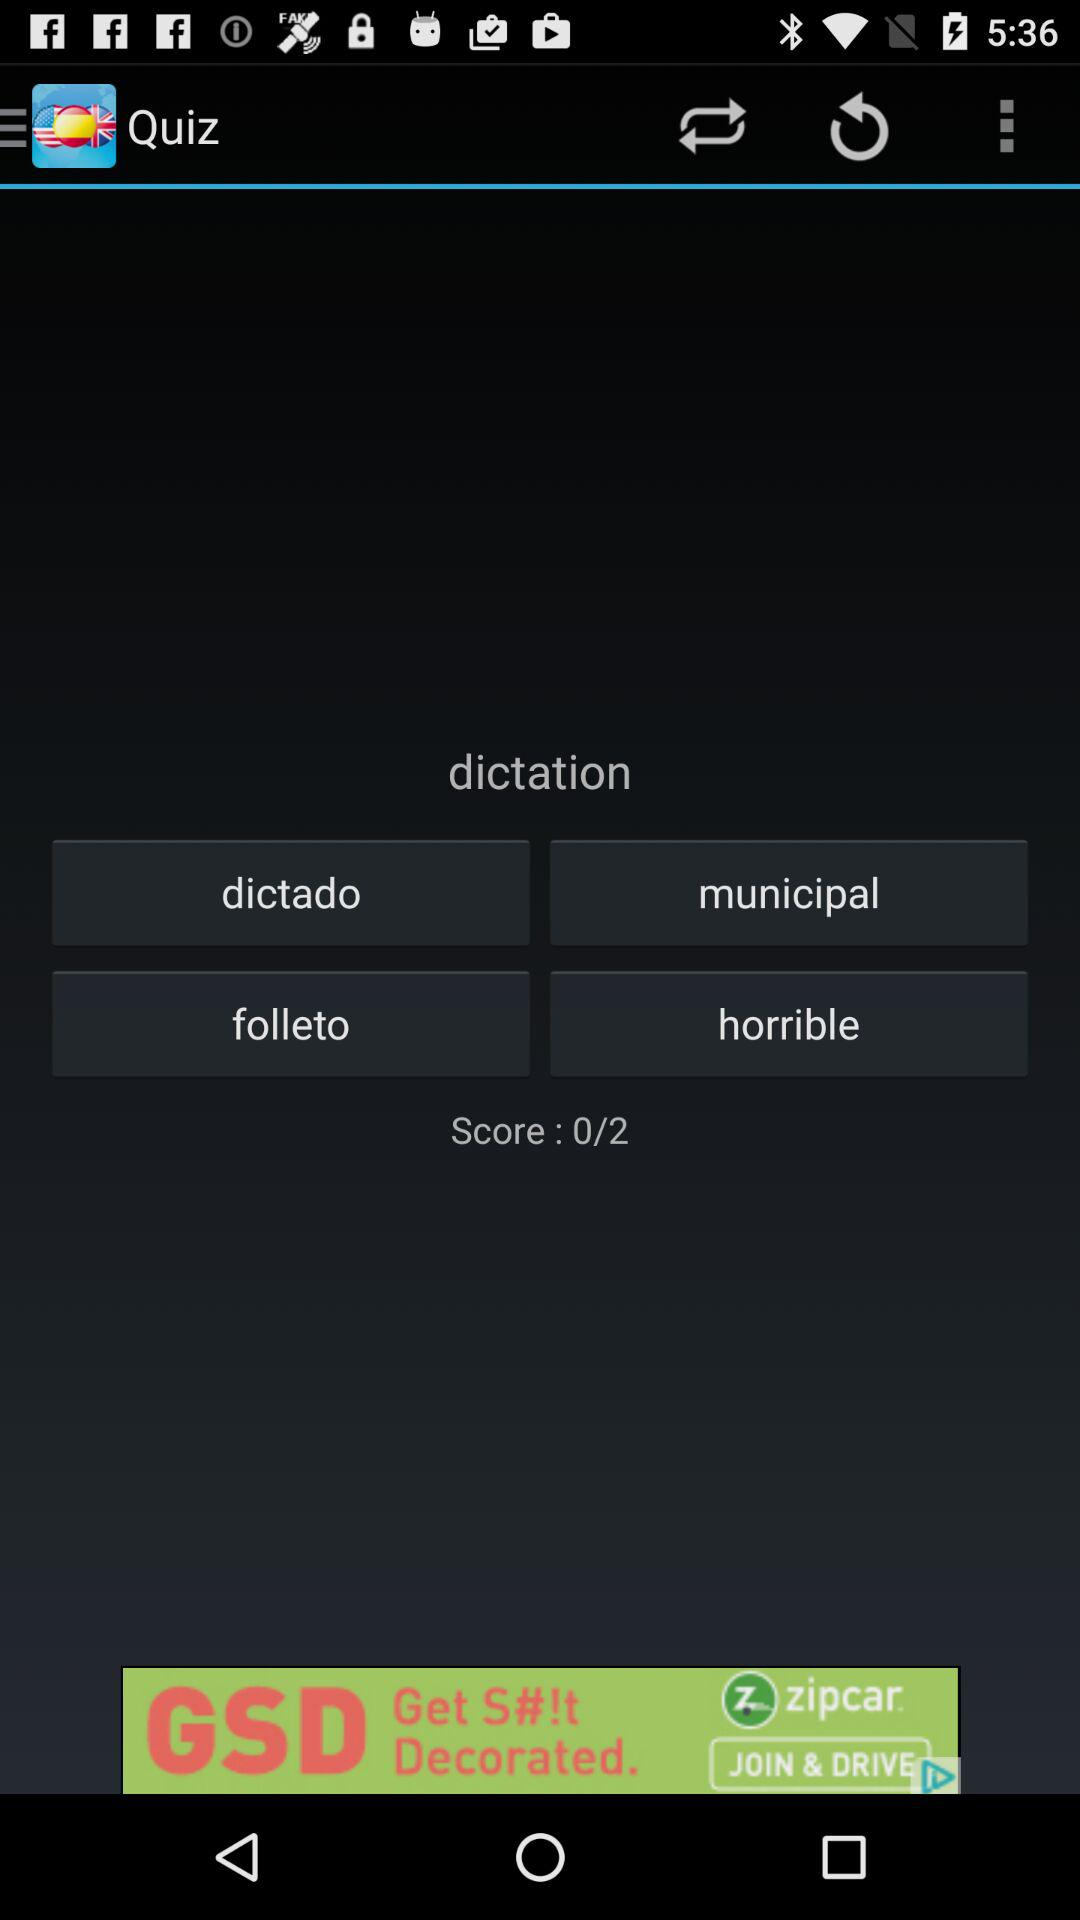How many points is the user currently on?
Answer the question using a single word or phrase. 0 